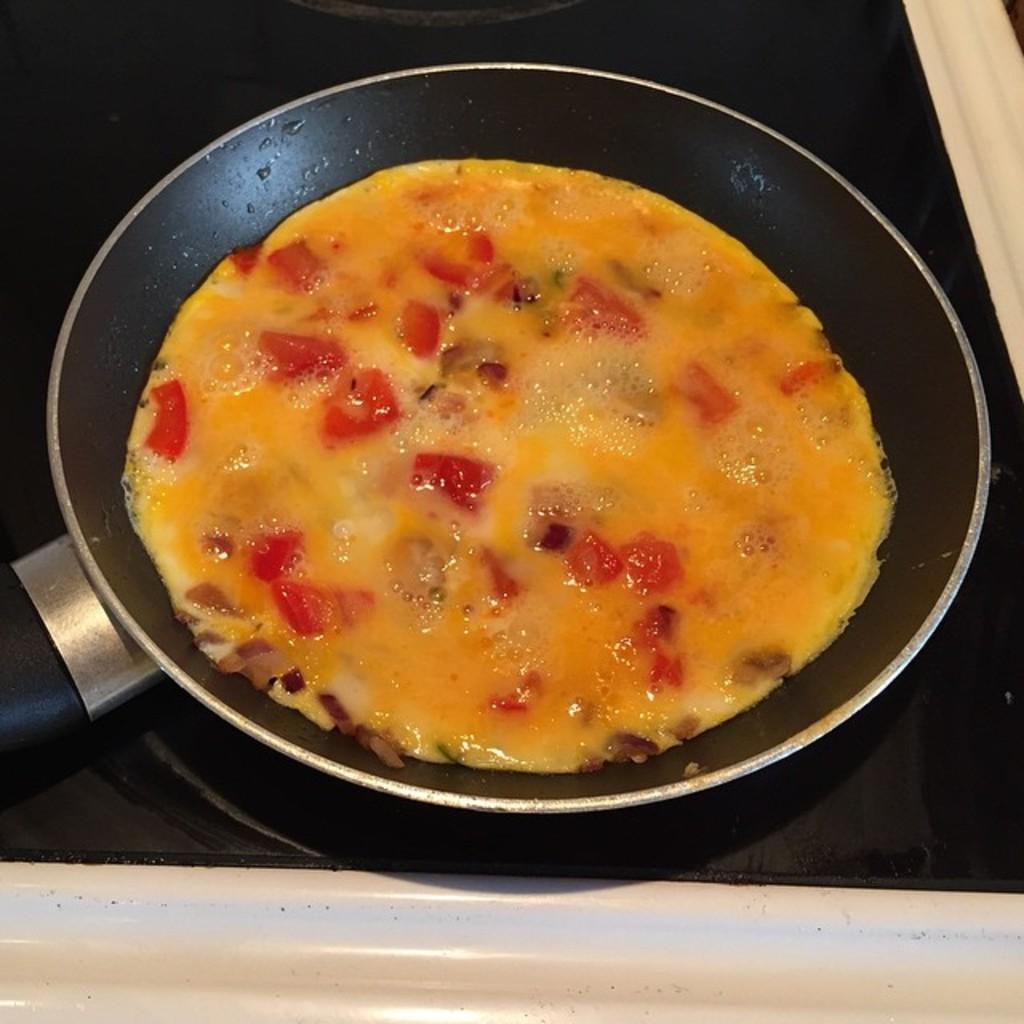Could you give a brief overview of what you see in this image? In this image we can see a pan with some dish. We can also see an induction stove. 